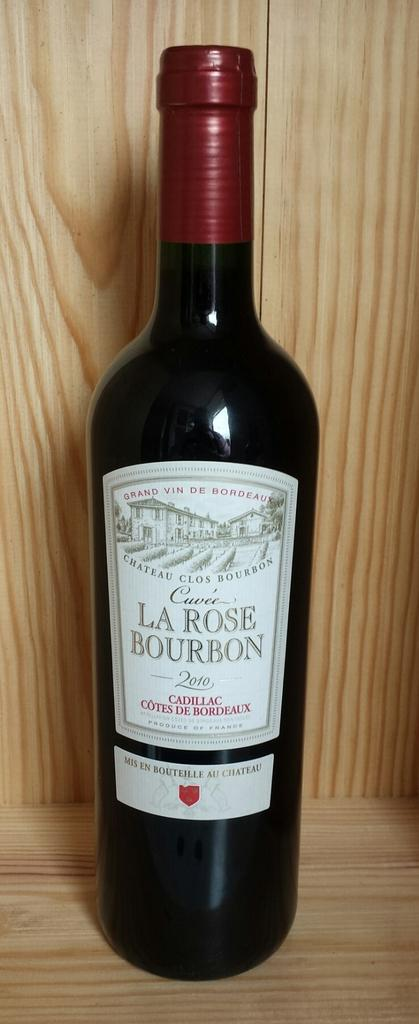<image>
Provide a brief description of the given image. The phrase "MIS EN BOUTEILLE AU CHATEAU" is labeled at the bottom of the wine bottle. 